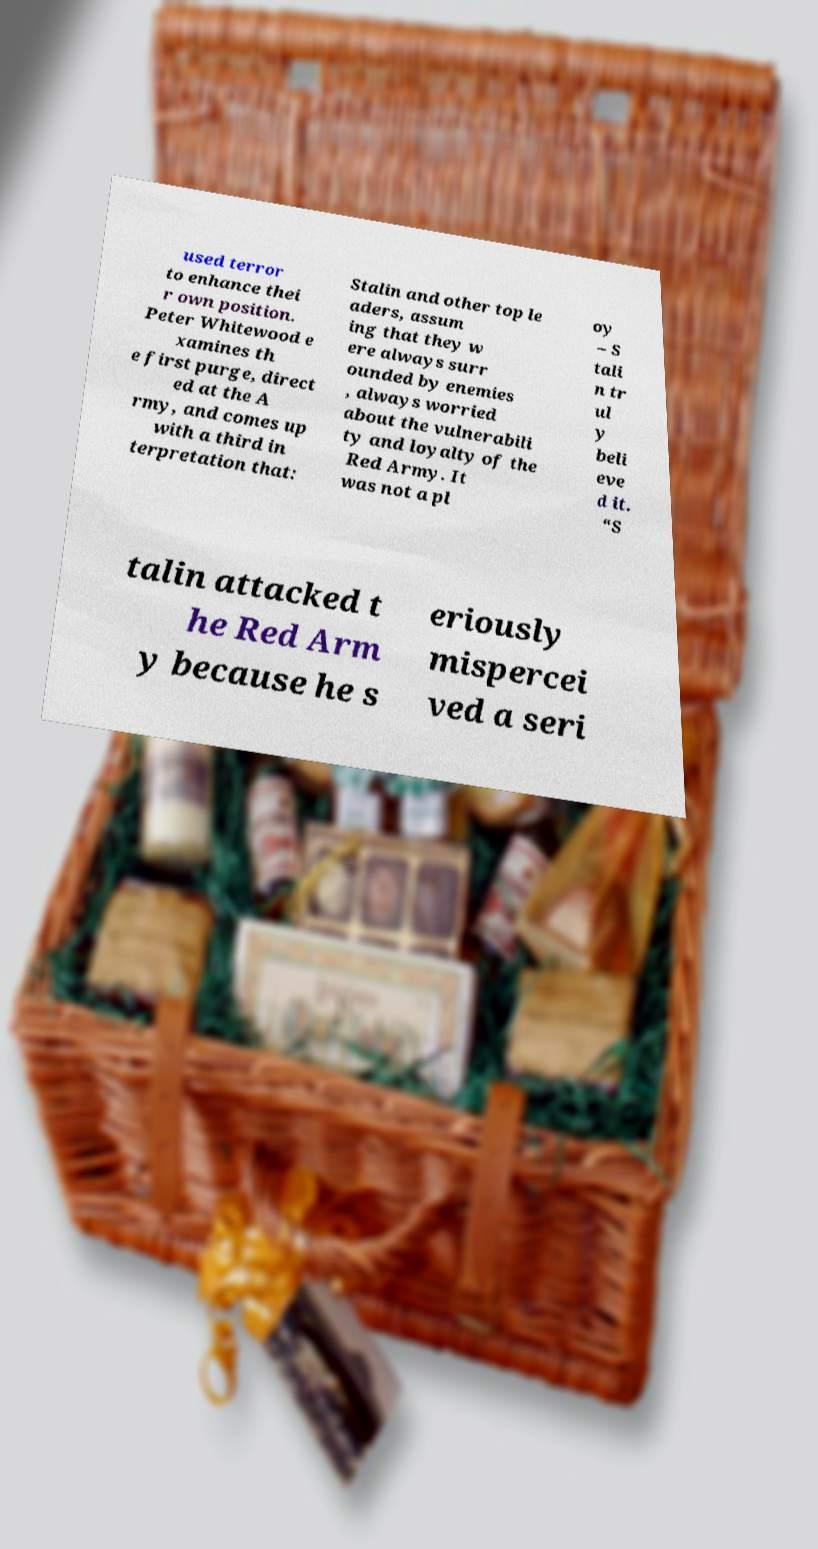Please read and relay the text visible in this image. What does it say? used terror to enhance thei r own position. Peter Whitewood e xamines th e first purge, direct ed at the A rmy, and comes up with a third in terpretation that: Stalin and other top le aders, assum ing that they w ere always surr ounded by enemies , always worried about the vulnerabili ty and loyalty of the Red Army. It was not a pl oy – S tali n tr ul y beli eve d it. “S talin attacked t he Red Arm y because he s eriously mispercei ved a seri 